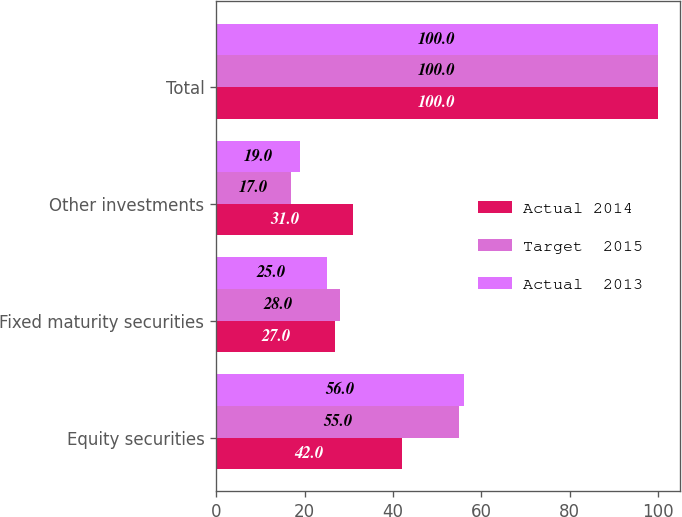Convert chart to OTSL. <chart><loc_0><loc_0><loc_500><loc_500><stacked_bar_chart><ecel><fcel>Equity securities<fcel>Fixed maturity securities<fcel>Other investments<fcel>Total<nl><fcel>Actual 2014<fcel>42<fcel>27<fcel>31<fcel>100<nl><fcel>Target  2015<fcel>55<fcel>28<fcel>17<fcel>100<nl><fcel>Actual  2013<fcel>56<fcel>25<fcel>19<fcel>100<nl></chart> 